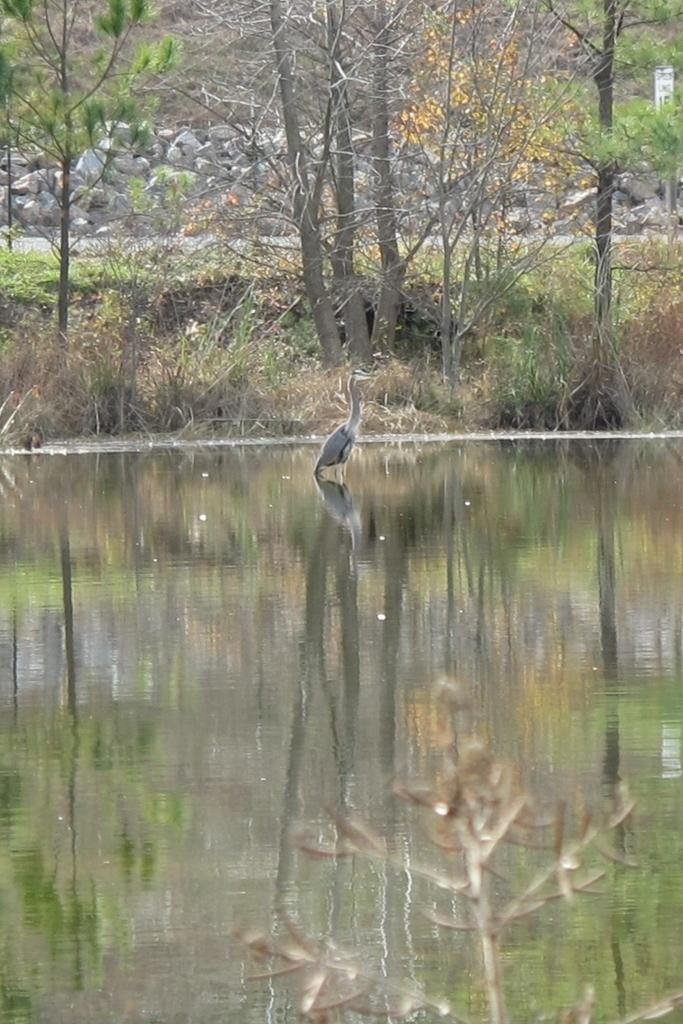What type of plant can be seen in the image? There is a tree in the image. What animal is present near the water in the image? There is a duck on the river in the image. What can be seen in the distance behind the tree? There are trees and a road in the background of the image. What type of terrain is visible in the background? There are stones in the background of the image. What effect does the duck have on the nerves of the tree in the image? There is no indication in the image that the duck has any effect on the nerves of the tree, as plants do not have nerves. 